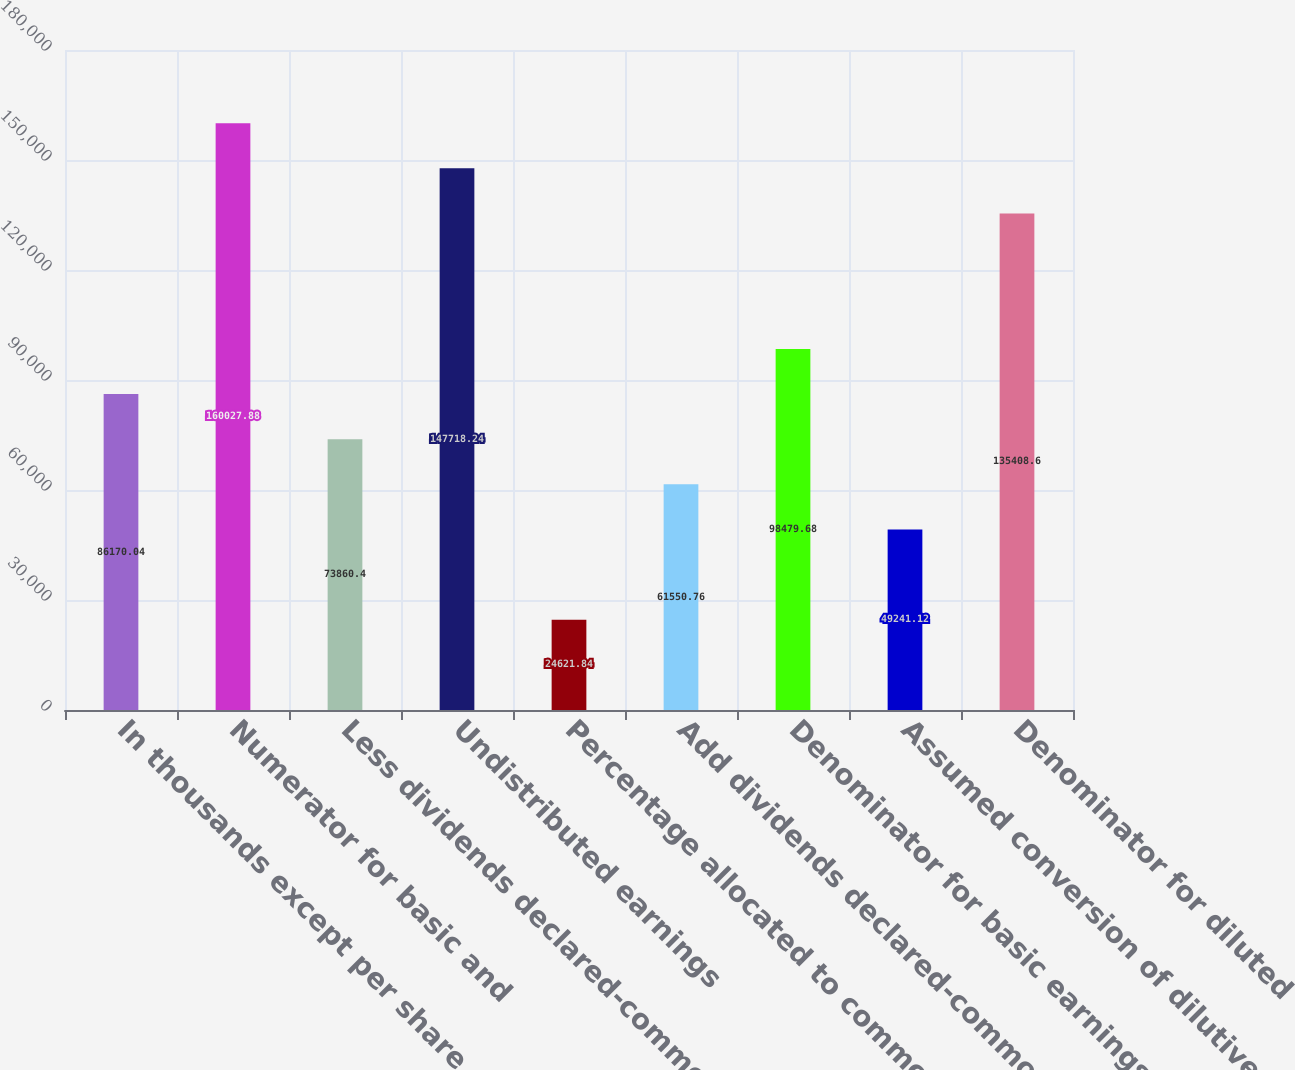Convert chart to OTSL. <chart><loc_0><loc_0><loc_500><loc_500><bar_chart><fcel>In thousands except per share<fcel>Numerator for basic and<fcel>Less dividends declared-common<fcel>Undistributed earnings<fcel>Percentage allocated to common<fcel>Add dividends declared-common<fcel>Denominator for basic earnings<fcel>Assumed conversion of dilutive<fcel>Denominator for diluted<nl><fcel>86170<fcel>160028<fcel>73860.4<fcel>147718<fcel>24621.8<fcel>61550.8<fcel>98479.7<fcel>49241.1<fcel>135409<nl></chart> 